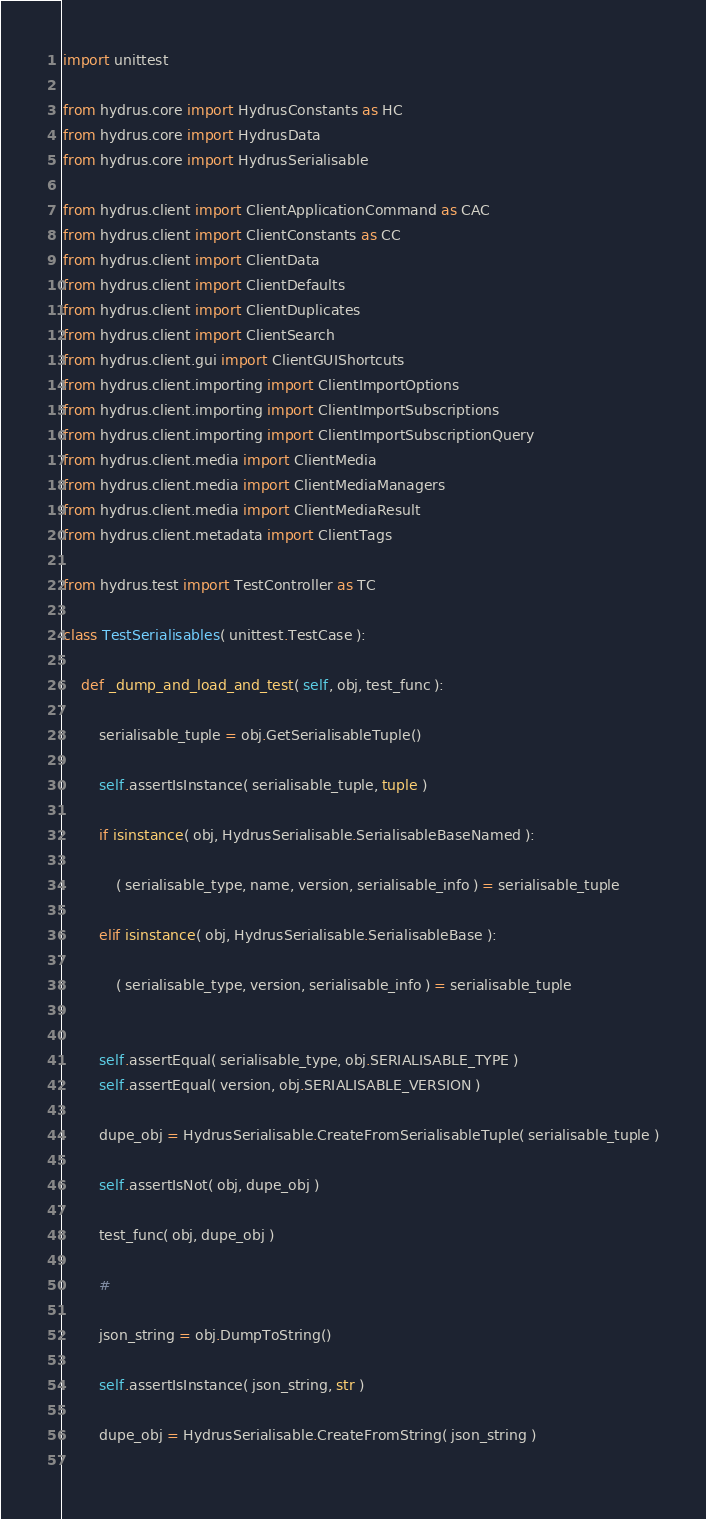Convert code to text. <code><loc_0><loc_0><loc_500><loc_500><_Python_>import unittest

from hydrus.core import HydrusConstants as HC
from hydrus.core import HydrusData
from hydrus.core import HydrusSerialisable

from hydrus.client import ClientApplicationCommand as CAC
from hydrus.client import ClientConstants as CC
from hydrus.client import ClientData
from hydrus.client import ClientDefaults
from hydrus.client import ClientDuplicates
from hydrus.client import ClientSearch
from hydrus.client.gui import ClientGUIShortcuts
from hydrus.client.importing import ClientImportOptions
from hydrus.client.importing import ClientImportSubscriptions
from hydrus.client.importing import ClientImportSubscriptionQuery
from hydrus.client.media import ClientMedia
from hydrus.client.media import ClientMediaManagers
from hydrus.client.media import ClientMediaResult
from hydrus.client.metadata import ClientTags

from hydrus.test import TestController as TC

class TestSerialisables( unittest.TestCase ):
    
    def _dump_and_load_and_test( self, obj, test_func ):
        
        serialisable_tuple = obj.GetSerialisableTuple()
        
        self.assertIsInstance( serialisable_tuple, tuple )
        
        if isinstance( obj, HydrusSerialisable.SerialisableBaseNamed ):
            
            ( serialisable_type, name, version, serialisable_info ) = serialisable_tuple
            
        elif isinstance( obj, HydrusSerialisable.SerialisableBase ):
            
            ( serialisable_type, version, serialisable_info ) = serialisable_tuple
            
        
        self.assertEqual( serialisable_type, obj.SERIALISABLE_TYPE )
        self.assertEqual( version, obj.SERIALISABLE_VERSION )
        
        dupe_obj = HydrusSerialisable.CreateFromSerialisableTuple( serialisable_tuple )
        
        self.assertIsNot( obj, dupe_obj )
        
        test_func( obj, dupe_obj )
        
        #
        
        json_string = obj.DumpToString()
        
        self.assertIsInstance( json_string, str )
        
        dupe_obj = HydrusSerialisable.CreateFromString( json_string )
        </code> 